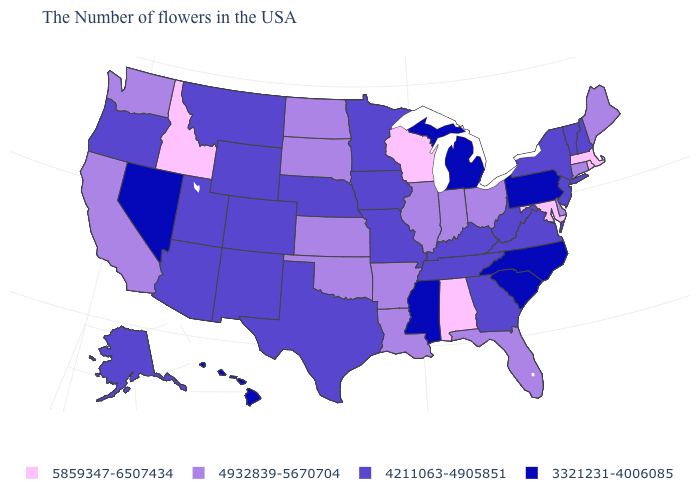Among the states that border Connecticut , which have the highest value?
Be succinct. Massachusetts, Rhode Island. What is the value of Nebraska?
Write a very short answer. 4211063-4905851. Name the states that have a value in the range 3321231-4006085?
Answer briefly. Pennsylvania, North Carolina, South Carolina, Michigan, Mississippi, Nevada, Hawaii. Is the legend a continuous bar?
Be succinct. No. Name the states that have a value in the range 5859347-6507434?
Keep it brief. Massachusetts, Rhode Island, Maryland, Alabama, Wisconsin, Idaho. Name the states that have a value in the range 4932839-5670704?
Be succinct. Maine, Connecticut, Delaware, Ohio, Florida, Indiana, Illinois, Louisiana, Arkansas, Kansas, Oklahoma, South Dakota, North Dakota, California, Washington. Does West Virginia have a higher value than Montana?
Short answer required. No. Does Wyoming have the lowest value in the USA?
Quick response, please. No. What is the value of North Carolina?
Give a very brief answer. 3321231-4006085. Name the states that have a value in the range 4211063-4905851?
Be succinct. New Hampshire, Vermont, New York, New Jersey, Virginia, West Virginia, Georgia, Kentucky, Tennessee, Missouri, Minnesota, Iowa, Nebraska, Texas, Wyoming, Colorado, New Mexico, Utah, Montana, Arizona, Oregon, Alaska. What is the value of Indiana?
Short answer required. 4932839-5670704. Among the states that border Connecticut , does New York have the lowest value?
Give a very brief answer. Yes. Does the map have missing data?
Short answer required. No. Name the states that have a value in the range 4211063-4905851?
Keep it brief. New Hampshire, Vermont, New York, New Jersey, Virginia, West Virginia, Georgia, Kentucky, Tennessee, Missouri, Minnesota, Iowa, Nebraska, Texas, Wyoming, Colorado, New Mexico, Utah, Montana, Arizona, Oregon, Alaska. Does Louisiana have a higher value than Arizona?
Concise answer only. Yes. 